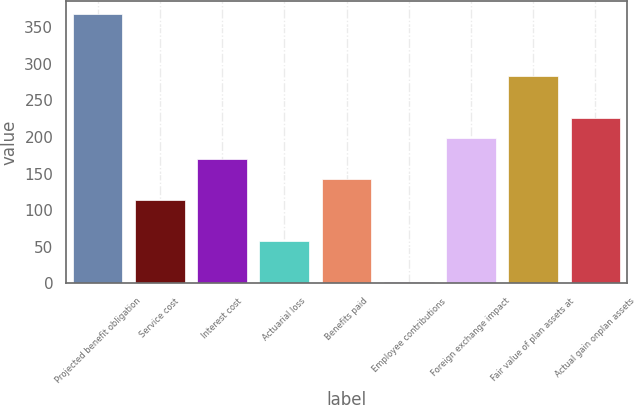Convert chart to OTSL. <chart><loc_0><loc_0><loc_500><loc_500><bar_chart><fcel>Projected benefit obligation<fcel>Service cost<fcel>Interest cost<fcel>Actuarial loss<fcel>Benefits paid<fcel>Employee contributions<fcel>Foreign exchange impact<fcel>Fair value of plan assets at<fcel>Actual gain onplan assets<nl><fcel>367.48<fcel>114.04<fcel>170.36<fcel>57.72<fcel>142.2<fcel>1.4<fcel>198.52<fcel>283<fcel>226.68<nl></chart> 